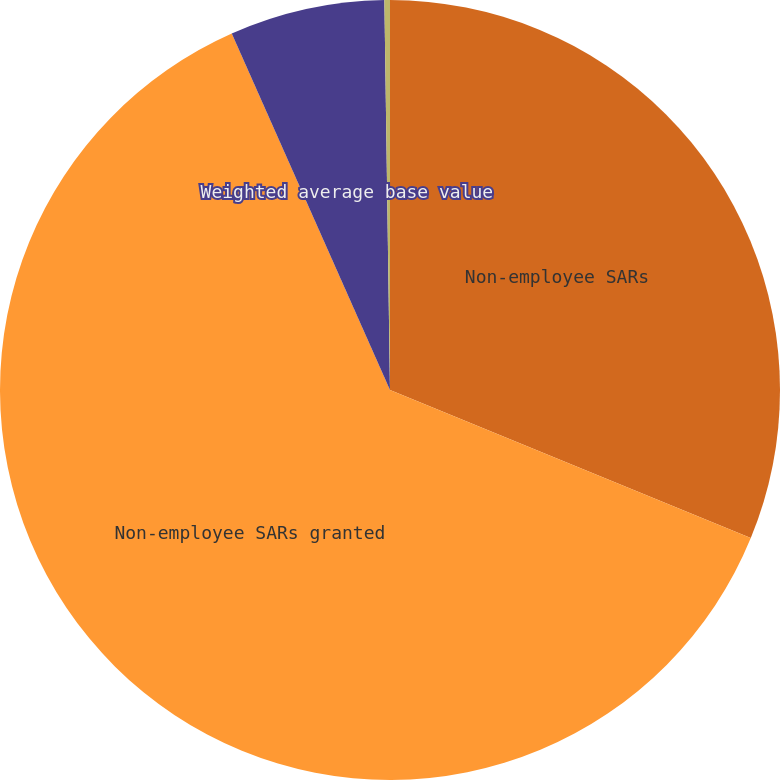Convert chart. <chart><loc_0><loc_0><loc_500><loc_500><pie_chart><fcel>Non-employee SARs<fcel>Non-employee SARs granted<fcel>Weighted average base value<fcel>Weighted average grant-date<nl><fcel>31.2%<fcel>62.15%<fcel>6.42%<fcel>0.23%<nl></chart> 